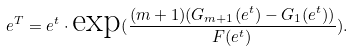Convert formula to latex. <formula><loc_0><loc_0><loc_500><loc_500>e ^ { T } = e ^ { t } \cdot \text {exp} ( \frac { ( m + 1 ) ( G _ { m + 1 } ( e ^ { t } ) - G _ { 1 } ( e ^ { t } ) ) } { F ( e ^ { t } ) } ) .</formula> 